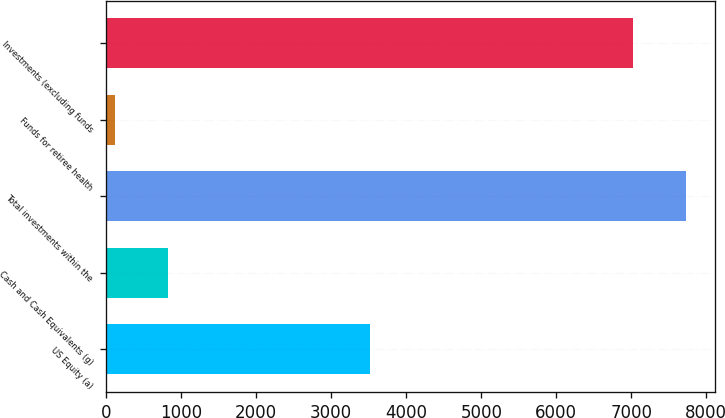Convert chart to OTSL. <chart><loc_0><loc_0><loc_500><loc_500><bar_chart><fcel>US Equity (a)<fcel>Cash and Cash Equivalents (g)<fcel>Total investments within the<fcel>Funds for retiree health<fcel>Investments (excluding funds<nl><fcel>3515<fcel>820.1<fcel>7723.1<fcel>118<fcel>7021<nl></chart> 